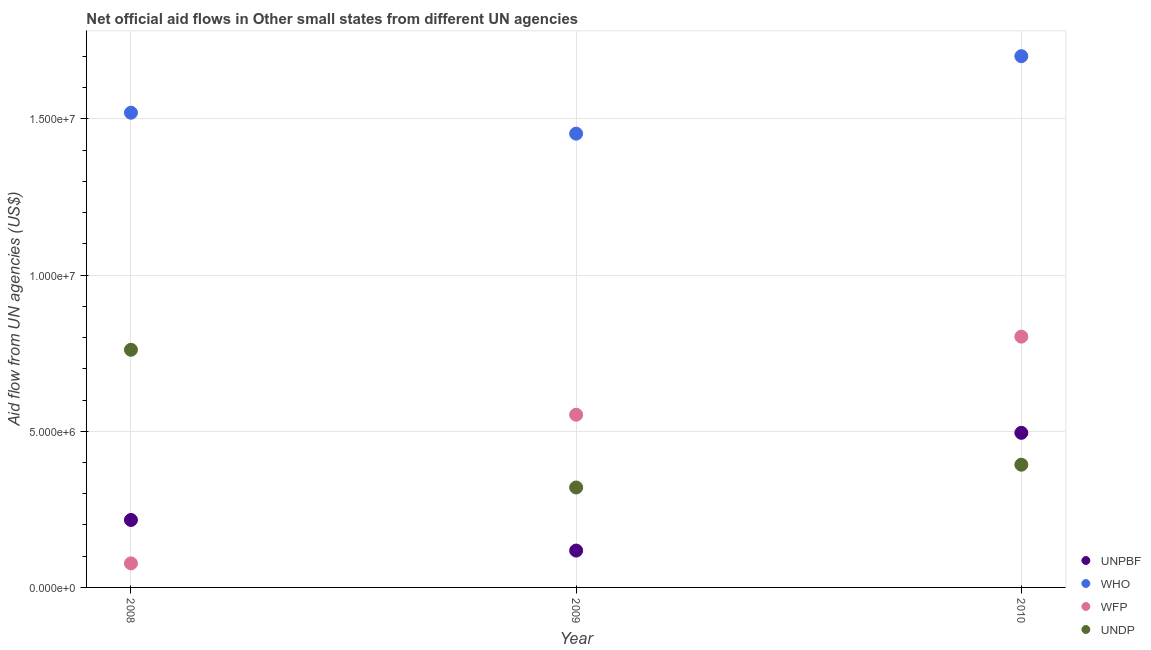How many different coloured dotlines are there?
Provide a short and direct response. 4. Is the number of dotlines equal to the number of legend labels?
Offer a very short reply. Yes. What is the amount of aid given by wfp in 2010?
Provide a succinct answer. 8.03e+06. Across all years, what is the maximum amount of aid given by wfp?
Ensure brevity in your answer.  8.03e+06. Across all years, what is the minimum amount of aid given by undp?
Provide a short and direct response. 3.20e+06. In which year was the amount of aid given by undp minimum?
Ensure brevity in your answer.  2009. What is the total amount of aid given by undp in the graph?
Offer a terse response. 1.47e+07. What is the difference between the amount of aid given by undp in 2009 and that in 2010?
Make the answer very short. -7.30e+05. What is the difference between the amount of aid given by undp in 2008 and the amount of aid given by unpbf in 2009?
Offer a terse response. 6.43e+06. What is the average amount of aid given by who per year?
Keep it short and to the point. 1.56e+07. In the year 2010, what is the difference between the amount of aid given by unpbf and amount of aid given by undp?
Make the answer very short. 1.02e+06. What is the ratio of the amount of aid given by undp in 2008 to that in 2010?
Offer a terse response. 1.94. Is the difference between the amount of aid given by undp in 2009 and 2010 greater than the difference between the amount of aid given by who in 2009 and 2010?
Offer a terse response. Yes. What is the difference between the highest and the second highest amount of aid given by undp?
Provide a succinct answer. 3.68e+06. What is the difference between the highest and the lowest amount of aid given by undp?
Your answer should be very brief. 4.41e+06. In how many years, is the amount of aid given by undp greater than the average amount of aid given by undp taken over all years?
Keep it short and to the point. 1. Is it the case that in every year, the sum of the amount of aid given by undp and amount of aid given by wfp is greater than the sum of amount of aid given by who and amount of aid given by unpbf?
Keep it short and to the point. No. Is the amount of aid given by undp strictly greater than the amount of aid given by unpbf over the years?
Provide a succinct answer. No. Is the amount of aid given by undp strictly less than the amount of aid given by who over the years?
Provide a succinct answer. Yes. How many dotlines are there?
Offer a very short reply. 4. How many years are there in the graph?
Offer a terse response. 3. How many legend labels are there?
Provide a succinct answer. 4. What is the title of the graph?
Give a very brief answer. Net official aid flows in Other small states from different UN agencies. Does "Efficiency of custom clearance process" appear as one of the legend labels in the graph?
Offer a very short reply. No. What is the label or title of the X-axis?
Ensure brevity in your answer.  Year. What is the label or title of the Y-axis?
Your answer should be compact. Aid flow from UN agencies (US$). What is the Aid flow from UN agencies (US$) of UNPBF in 2008?
Give a very brief answer. 2.16e+06. What is the Aid flow from UN agencies (US$) in WHO in 2008?
Keep it short and to the point. 1.52e+07. What is the Aid flow from UN agencies (US$) in WFP in 2008?
Keep it short and to the point. 7.70e+05. What is the Aid flow from UN agencies (US$) in UNDP in 2008?
Provide a succinct answer. 7.61e+06. What is the Aid flow from UN agencies (US$) in UNPBF in 2009?
Your answer should be compact. 1.18e+06. What is the Aid flow from UN agencies (US$) in WHO in 2009?
Ensure brevity in your answer.  1.45e+07. What is the Aid flow from UN agencies (US$) in WFP in 2009?
Your answer should be very brief. 5.53e+06. What is the Aid flow from UN agencies (US$) of UNDP in 2009?
Your response must be concise. 3.20e+06. What is the Aid flow from UN agencies (US$) in UNPBF in 2010?
Your answer should be compact. 4.95e+06. What is the Aid flow from UN agencies (US$) in WHO in 2010?
Provide a short and direct response. 1.70e+07. What is the Aid flow from UN agencies (US$) of WFP in 2010?
Keep it short and to the point. 8.03e+06. What is the Aid flow from UN agencies (US$) of UNDP in 2010?
Your response must be concise. 3.93e+06. Across all years, what is the maximum Aid flow from UN agencies (US$) of UNPBF?
Your response must be concise. 4.95e+06. Across all years, what is the maximum Aid flow from UN agencies (US$) in WHO?
Your answer should be very brief. 1.70e+07. Across all years, what is the maximum Aid flow from UN agencies (US$) in WFP?
Make the answer very short. 8.03e+06. Across all years, what is the maximum Aid flow from UN agencies (US$) in UNDP?
Give a very brief answer. 7.61e+06. Across all years, what is the minimum Aid flow from UN agencies (US$) of UNPBF?
Your answer should be very brief. 1.18e+06. Across all years, what is the minimum Aid flow from UN agencies (US$) in WHO?
Offer a very short reply. 1.45e+07. Across all years, what is the minimum Aid flow from UN agencies (US$) of WFP?
Give a very brief answer. 7.70e+05. Across all years, what is the minimum Aid flow from UN agencies (US$) of UNDP?
Offer a terse response. 3.20e+06. What is the total Aid flow from UN agencies (US$) in UNPBF in the graph?
Give a very brief answer. 8.29e+06. What is the total Aid flow from UN agencies (US$) in WHO in the graph?
Make the answer very short. 4.67e+07. What is the total Aid flow from UN agencies (US$) of WFP in the graph?
Offer a terse response. 1.43e+07. What is the total Aid flow from UN agencies (US$) in UNDP in the graph?
Provide a succinct answer. 1.47e+07. What is the difference between the Aid flow from UN agencies (US$) in UNPBF in 2008 and that in 2009?
Provide a succinct answer. 9.80e+05. What is the difference between the Aid flow from UN agencies (US$) in WHO in 2008 and that in 2009?
Keep it short and to the point. 6.70e+05. What is the difference between the Aid flow from UN agencies (US$) of WFP in 2008 and that in 2009?
Provide a short and direct response. -4.76e+06. What is the difference between the Aid flow from UN agencies (US$) in UNDP in 2008 and that in 2009?
Your response must be concise. 4.41e+06. What is the difference between the Aid flow from UN agencies (US$) in UNPBF in 2008 and that in 2010?
Offer a very short reply. -2.79e+06. What is the difference between the Aid flow from UN agencies (US$) of WHO in 2008 and that in 2010?
Give a very brief answer. -1.81e+06. What is the difference between the Aid flow from UN agencies (US$) in WFP in 2008 and that in 2010?
Your answer should be very brief. -7.26e+06. What is the difference between the Aid flow from UN agencies (US$) in UNDP in 2008 and that in 2010?
Make the answer very short. 3.68e+06. What is the difference between the Aid flow from UN agencies (US$) of UNPBF in 2009 and that in 2010?
Offer a very short reply. -3.77e+06. What is the difference between the Aid flow from UN agencies (US$) in WHO in 2009 and that in 2010?
Offer a very short reply. -2.48e+06. What is the difference between the Aid flow from UN agencies (US$) of WFP in 2009 and that in 2010?
Offer a very short reply. -2.50e+06. What is the difference between the Aid flow from UN agencies (US$) of UNDP in 2009 and that in 2010?
Your answer should be compact. -7.30e+05. What is the difference between the Aid flow from UN agencies (US$) in UNPBF in 2008 and the Aid flow from UN agencies (US$) in WHO in 2009?
Give a very brief answer. -1.24e+07. What is the difference between the Aid flow from UN agencies (US$) of UNPBF in 2008 and the Aid flow from UN agencies (US$) of WFP in 2009?
Ensure brevity in your answer.  -3.37e+06. What is the difference between the Aid flow from UN agencies (US$) of UNPBF in 2008 and the Aid flow from UN agencies (US$) of UNDP in 2009?
Your answer should be very brief. -1.04e+06. What is the difference between the Aid flow from UN agencies (US$) in WHO in 2008 and the Aid flow from UN agencies (US$) in WFP in 2009?
Provide a succinct answer. 9.67e+06. What is the difference between the Aid flow from UN agencies (US$) of WHO in 2008 and the Aid flow from UN agencies (US$) of UNDP in 2009?
Your answer should be very brief. 1.20e+07. What is the difference between the Aid flow from UN agencies (US$) in WFP in 2008 and the Aid flow from UN agencies (US$) in UNDP in 2009?
Offer a very short reply. -2.43e+06. What is the difference between the Aid flow from UN agencies (US$) in UNPBF in 2008 and the Aid flow from UN agencies (US$) in WHO in 2010?
Your response must be concise. -1.48e+07. What is the difference between the Aid flow from UN agencies (US$) in UNPBF in 2008 and the Aid flow from UN agencies (US$) in WFP in 2010?
Ensure brevity in your answer.  -5.87e+06. What is the difference between the Aid flow from UN agencies (US$) in UNPBF in 2008 and the Aid flow from UN agencies (US$) in UNDP in 2010?
Offer a terse response. -1.77e+06. What is the difference between the Aid flow from UN agencies (US$) in WHO in 2008 and the Aid flow from UN agencies (US$) in WFP in 2010?
Offer a very short reply. 7.17e+06. What is the difference between the Aid flow from UN agencies (US$) in WHO in 2008 and the Aid flow from UN agencies (US$) in UNDP in 2010?
Provide a short and direct response. 1.13e+07. What is the difference between the Aid flow from UN agencies (US$) of WFP in 2008 and the Aid flow from UN agencies (US$) of UNDP in 2010?
Your answer should be very brief. -3.16e+06. What is the difference between the Aid flow from UN agencies (US$) of UNPBF in 2009 and the Aid flow from UN agencies (US$) of WHO in 2010?
Give a very brief answer. -1.58e+07. What is the difference between the Aid flow from UN agencies (US$) of UNPBF in 2009 and the Aid flow from UN agencies (US$) of WFP in 2010?
Make the answer very short. -6.85e+06. What is the difference between the Aid flow from UN agencies (US$) of UNPBF in 2009 and the Aid flow from UN agencies (US$) of UNDP in 2010?
Make the answer very short. -2.75e+06. What is the difference between the Aid flow from UN agencies (US$) in WHO in 2009 and the Aid flow from UN agencies (US$) in WFP in 2010?
Offer a terse response. 6.50e+06. What is the difference between the Aid flow from UN agencies (US$) in WHO in 2009 and the Aid flow from UN agencies (US$) in UNDP in 2010?
Ensure brevity in your answer.  1.06e+07. What is the difference between the Aid flow from UN agencies (US$) in WFP in 2009 and the Aid flow from UN agencies (US$) in UNDP in 2010?
Provide a short and direct response. 1.60e+06. What is the average Aid flow from UN agencies (US$) in UNPBF per year?
Keep it short and to the point. 2.76e+06. What is the average Aid flow from UN agencies (US$) in WHO per year?
Give a very brief answer. 1.56e+07. What is the average Aid flow from UN agencies (US$) in WFP per year?
Offer a terse response. 4.78e+06. What is the average Aid flow from UN agencies (US$) of UNDP per year?
Offer a terse response. 4.91e+06. In the year 2008, what is the difference between the Aid flow from UN agencies (US$) of UNPBF and Aid flow from UN agencies (US$) of WHO?
Ensure brevity in your answer.  -1.30e+07. In the year 2008, what is the difference between the Aid flow from UN agencies (US$) of UNPBF and Aid flow from UN agencies (US$) of WFP?
Make the answer very short. 1.39e+06. In the year 2008, what is the difference between the Aid flow from UN agencies (US$) of UNPBF and Aid flow from UN agencies (US$) of UNDP?
Offer a very short reply. -5.45e+06. In the year 2008, what is the difference between the Aid flow from UN agencies (US$) of WHO and Aid flow from UN agencies (US$) of WFP?
Provide a succinct answer. 1.44e+07. In the year 2008, what is the difference between the Aid flow from UN agencies (US$) in WHO and Aid flow from UN agencies (US$) in UNDP?
Make the answer very short. 7.59e+06. In the year 2008, what is the difference between the Aid flow from UN agencies (US$) in WFP and Aid flow from UN agencies (US$) in UNDP?
Your answer should be compact. -6.84e+06. In the year 2009, what is the difference between the Aid flow from UN agencies (US$) in UNPBF and Aid flow from UN agencies (US$) in WHO?
Offer a terse response. -1.34e+07. In the year 2009, what is the difference between the Aid flow from UN agencies (US$) in UNPBF and Aid flow from UN agencies (US$) in WFP?
Provide a short and direct response. -4.35e+06. In the year 2009, what is the difference between the Aid flow from UN agencies (US$) of UNPBF and Aid flow from UN agencies (US$) of UNDP?
Your answer should be compact. -2.02e+06. In the year 2009, what is the difference between the Aid flow from UN agencies (US$) of WHO and Aid flow from UN agencies (US$) of WFP?
Offer a very short reply. 9.00e+06. In the year 2009, what is the difference between the Aid flow from UN agencies (US$) in WHO and Aid flow from UN agencies (US$) in UNDP?
Your response must be concise. 1.13e+07. In the year 2009, what is the difference between the Aid flow from UN agencies (US$) in WFP and Aid flow from UN agencies (US$) in UNDP?
Keep it short and to the point. 2.33e+06. In the year 2010, what is the difference between the Aid flow from UN agencies (US$) of UNPBF and Aid flow from UN agencies (US$) of WHO?
Your answer should be compact. -1.21e+07. In the year 2010, what is the difference between the Aid flow from UN agencies (US$) in UNPBF and Aid flow from UN agencies (US$) in WFP?
Provide a succinct answer. -3.08e+06. In the year 2010, what is the difference between the Aid flow from UN agencies (US$) of UNPBF and Aid flow from UN agencies (US$) of UNDP?
Offer a terse response. 1.02e+06. In the year 2010, what is the difference between the Aid flow from UN agencies (US$) of WHO and Aid flow from UN agencies (US$) of WFP?
Your response must be concise. 8.98e+06. In the year 2010, what is the difference between the Aid flow from UN agencies (US$) in WHO and Aid flow from UN agencies (US$) in UNDP?
Offer a very short reply. 1.31e+07. In the year 2010, what is the difference between the Aid flow from UN agencies (US$) in WFP and Aid flow from UN agencies (US$) in UNDP?
Make the answer very short. 4.10e+06. What is the ratio of the Aid flow from UN agencies (US$) of UNPBF in 2008 to that in 2009?
Keep it short and to the point. 1.83. What is the ratio of the Aid flow from UN agencies (US$) of WHO in 2008 to that in 2009?
Keep it short and to the point. 1.05. What is the ratio of the Aid flow from UN agencies (US$) of WFP in 2008 to that in 2009?
Your answer should be very brief. 0.14. What is the ratio of the Aid flow from UN agencies (US$) of UNDP in 2008 to that in 2009?
Give a very brief answer. 2.38. What is the ratio of the Aid flow from UN agencies (US$) of UNPBF in 2008 to that in 2010?
Ensure brevity in your answer.  0.44. What is the ratio of the Aid flow from UN agencies (US$) in WHO in 2008 to that in 2010?
Offer a terse response. 0.89. What is the ratio of the Aid flow from UN agencies (US$) in WFP in 2008 to that in 2010?
Your answer should be very brief. 0.1. What is the ratio of the Aid flow from UN agencies (US$) in UNDP in 2008 to that in 2010?
Ensure brevity in your answer.  1.94. What is the ratio of the Aid flow from UN agencies (US$) of UNPBF in 2009 to that in 2010?
Ensure brevity in your answer.  0.24. What is the ratio of the Aid flow from UN agencies (US$) in WHO in 2009 to that in 2010?
Give a very brief answer. 0.85. What is the ratio of the Aid flow from UN agencies (US$) of WFP in 2009 to that in 2010?
Ensure brevity in your answer.  0.69. What is the ratio of the Aid flow from UN agencies (US$) in UNDP in 2009 to that in 2010?
Your response must be concise. 0.81. What is the difference between the highest and the second highest Aid flow from UN agencies (US$) of UNPBF?
Make the answer very short. 2.79e+06. What is the difference between the highest and the second highest Aid flow from UN agencies (US$) in WHO?
Ensure brevity in your answer.  1.81e+06. What is the difference between the highest and the second highest Aid flow from UN agencies (US$) in WFP?
Ensure brevity in your answer.  2.50e+06. What is the difference between the highest and the second highest Aid flow from UN agencies (US$) in UNDP?
Give a very brief answer. 3.68e+06. What is the difference between the highest and the lowest Aid flow from UN agencies (US$) of UNPBF?
Your answer should be very brief. 3.77e+06. What is the difference between the highest and the lowest Aid flow from UN agencies (US$) in WHO?
Provide a short and direct response. 2.48e+06. What is the difference between the highest and the lowest Aid flow from UN agencies (US$) of WFP?
Your response must be concise. 7.26e+06. What is the difference between the highest and the lowest Aid flow from UN agencies (US$) in UNDP?
Provide a short and direct response. 4.41e+06. 